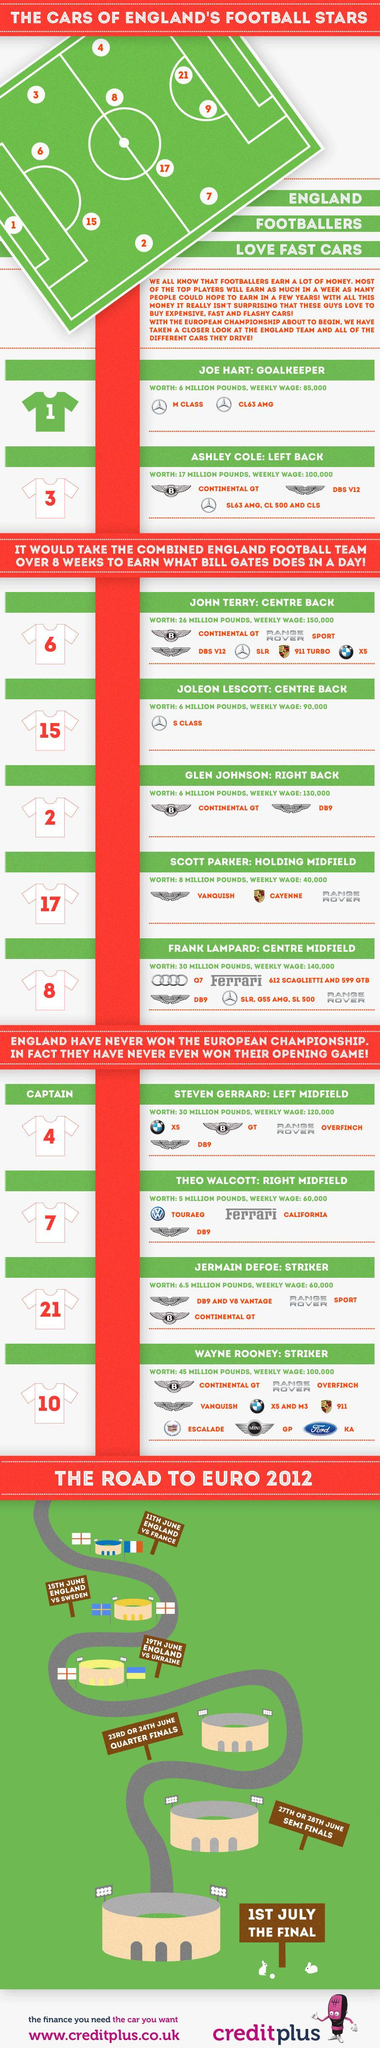What is the Jersey number of Joe Hart?
Answer the question with a short phrase. 1 What is the model no of Bentley used by John Terry? CONTINENTAL GT What is the Jersey no of Wayne Rooney? 10 How many cars are owned by John Terry? 6 What is the model of Range Rover used by Jermain Defoe? SPORT What is the model no of Mercedes Benz used by Ashley Cole? SL63 AMG, CL 500 and CLS How many cars are owned by Wayne Rooney? 8 Which model of Audi car is used by Frank Lampard? Q7 How many cars are owned by Glen Johnson? 2 How many series of Mercedes Benz are used by Frank Lampard? 3 